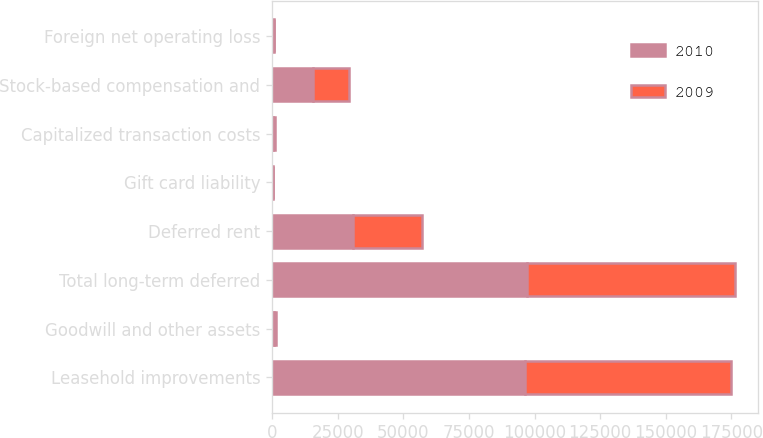Convert chart to OTSL. <chart><loc_0><loc_0><loc_500><loc_500><stacked_bar_chart><ecel><fcel>Leasehold improvements<fcel>Goodwill and other assets<fcel>Total long-term deferred<fcel>Deferred rent<fcel>Gift card liability<fcel>Capitalized transaction costs<fcel>Stock-based compensation and<fcel>Foreign net operating loss<nl><fcel>2010<fcel>96399<fcel>815<fcel>97214<fcel>30806<fcel>271<fcel>502<fcel>15548<fcel>617<nl><fcel>2009<fcel>78504<fcel>647<fcel>79151<fcel>26319<fcel>210<fcel>503<fcel>13696<fcel>200<nl></chart> 